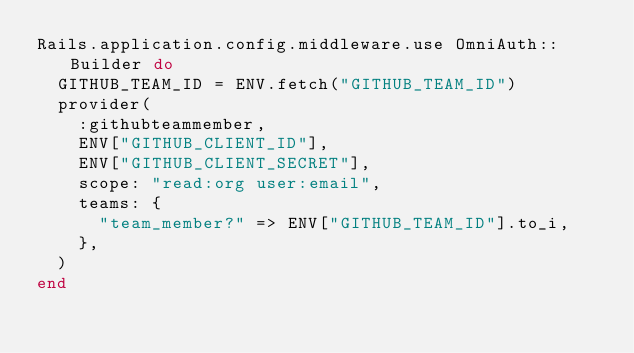Convert code to text. <code><loc_0><loc_0><loc_500><loc_500><_Ruby_>Rails.application.config.middleware.use OmniAuth::Builder do
  GITHUB_TEAM_ID = ENV.fetch("GITHUB_TEAM_ID")
  provider(
    :githubteammember,
    ENV["GITHUB_CLIENT_ID"],
    ENV["GITHUB_CLIENT_SECRET"],
    scope: "read:org user:email",
    teams: {
      "team_member?" => ENV["GITHUB_TEAM_ID"].to_i,
    },
  )
end
</code> 